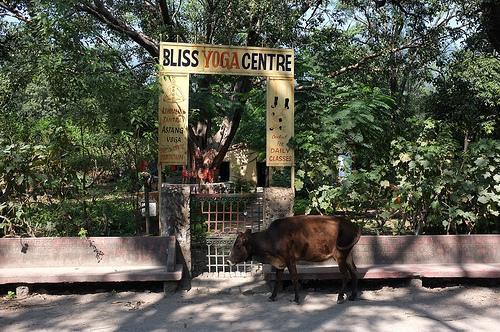How many animals are in the picture?
Give a very brief answer. 1. 